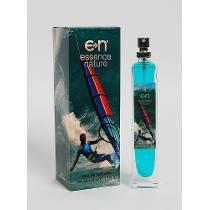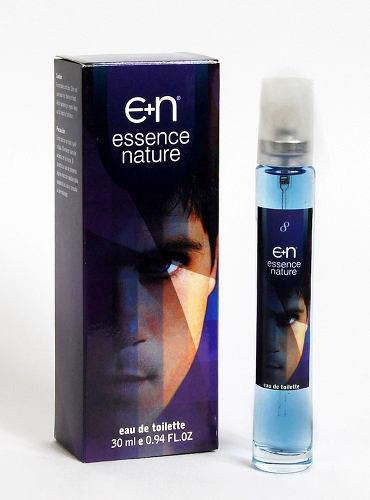The first image is the image on the left, the second image is the image on the right. For the images displayed, is the sentence "A young woman is featured on the front of the bottle." factually correct? Answer yes or no. No. The first image is the image on the left, the second image is the image on the right. Analyze the images presented: Is the assertion "Both images shows a perfume box with a human being on it." valid? Answer yes or no. Yes. 